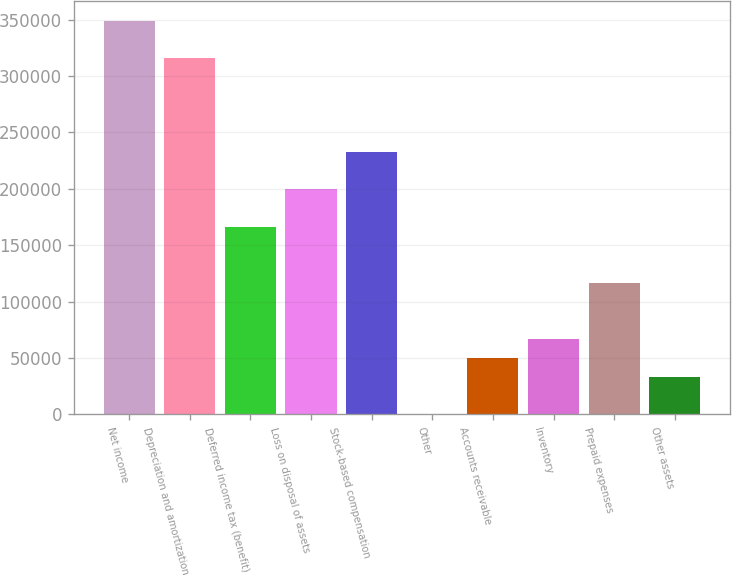Convert chart to OTSL. <chart><loc_0><loc_0><loc_500><loc_500><bar_chart><fcel>Net income<fcel>Depreciation and amortization<fcel>Deferred income tax (benefit)<fcel>Loss on disposal of assets<fcel>Stock-based compensation<fcel>Other<fcel>Accounts receivable<fcel>Inventory<fcel>Prepaid expenses<fcel>Other assets<nl><fcel>349031<fcel>315791<fcel>166213<fcel>199453<fcel>232692<fcel>15<fcel>49874.4<fcel>66494.2<fcel>116354<fcel>33254.6<nl></chart> 